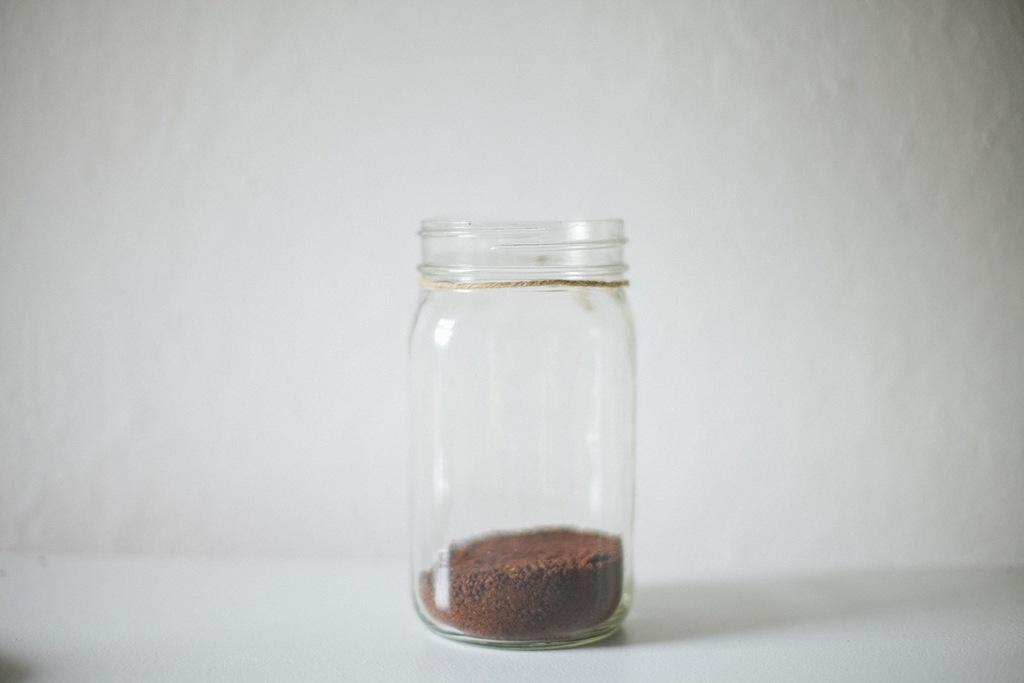What object is visible in the image? There is a glass tumbler in the image. What is at the bottom of the glass tumbler? There is soil at the bottom of the glass tumbler. What channel is your uncle watching on vacation in the image? There is no channel, uncle, or vacation mentioned in the image; it only features a glass tumbler with soil at the bottom. 